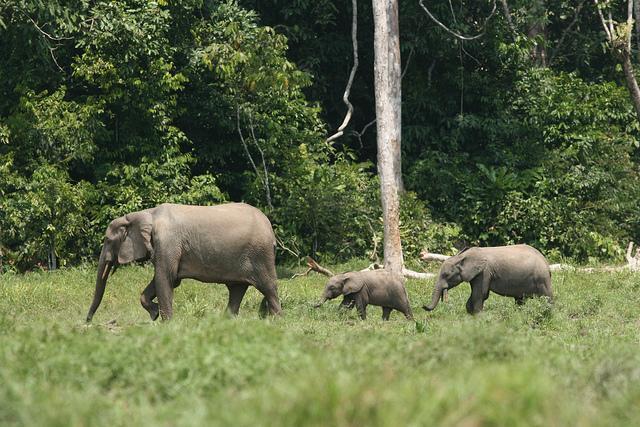How many elephants are in the picture?
Give a very brief answer. 3. How many people are outside of the train?
Give a very brief answer. 0. 